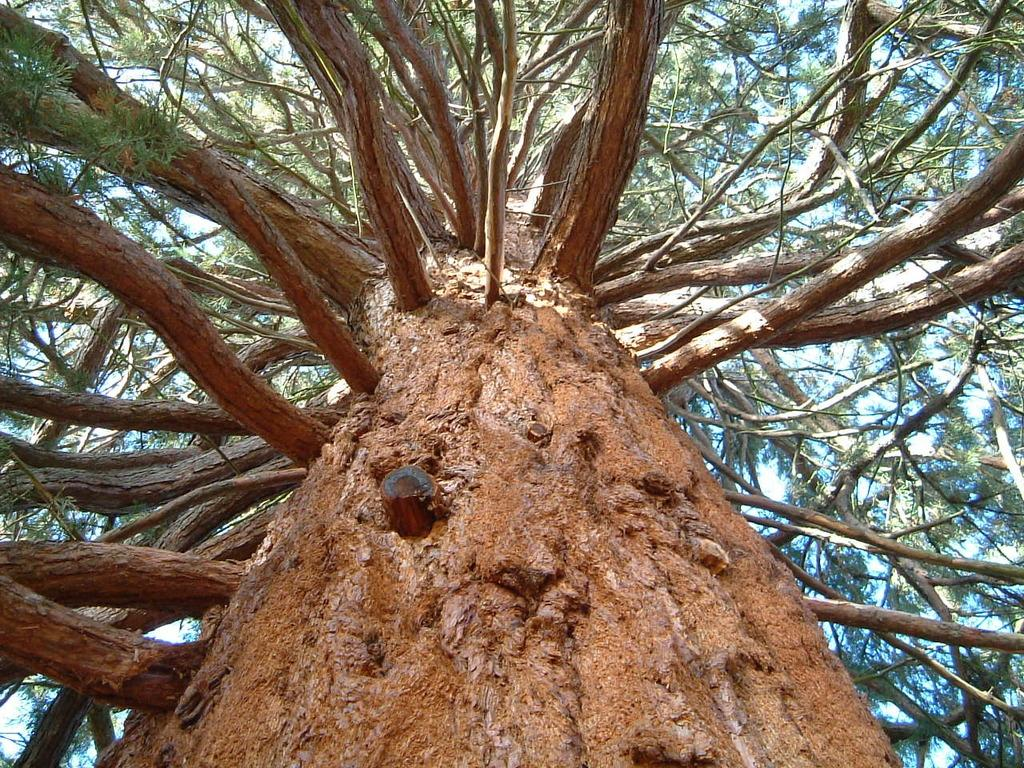What type of natural object can be seen in the image? There is a tree in the image. What part of the natural environment is visible in the image? The sky is visible in the image. What type of clothing is hanging from the tree in the image? There is no clothing present in the image; it only features a tree and the sky. What type of seafood is visible in the image? There is no seafood present in the image; it only features a tree and the sky. 